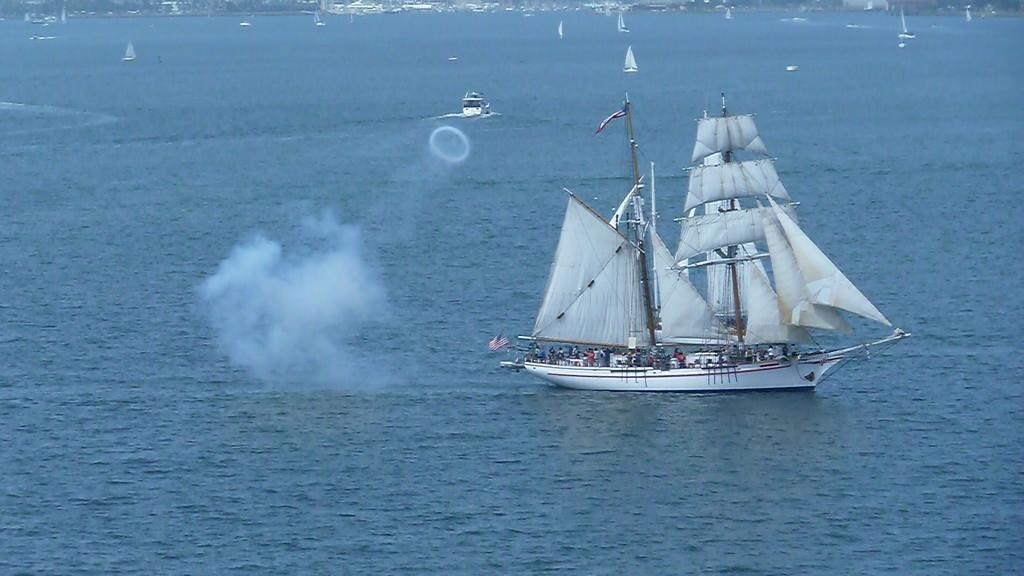What is the main subject of the image? There is a ship in the image. Are there any people visible in the image? Yes, there are people in the image. What else can be seen in the image besides the ship and people? There are other objects in the image. What is at the bottom of the image? The bottom of the image contains water. What can be seen in the background of the image? In the background of the image, there are ships, water, and other objects. What type of machine is used to crush the lace in the image? There is no machine or lace present in the image. 